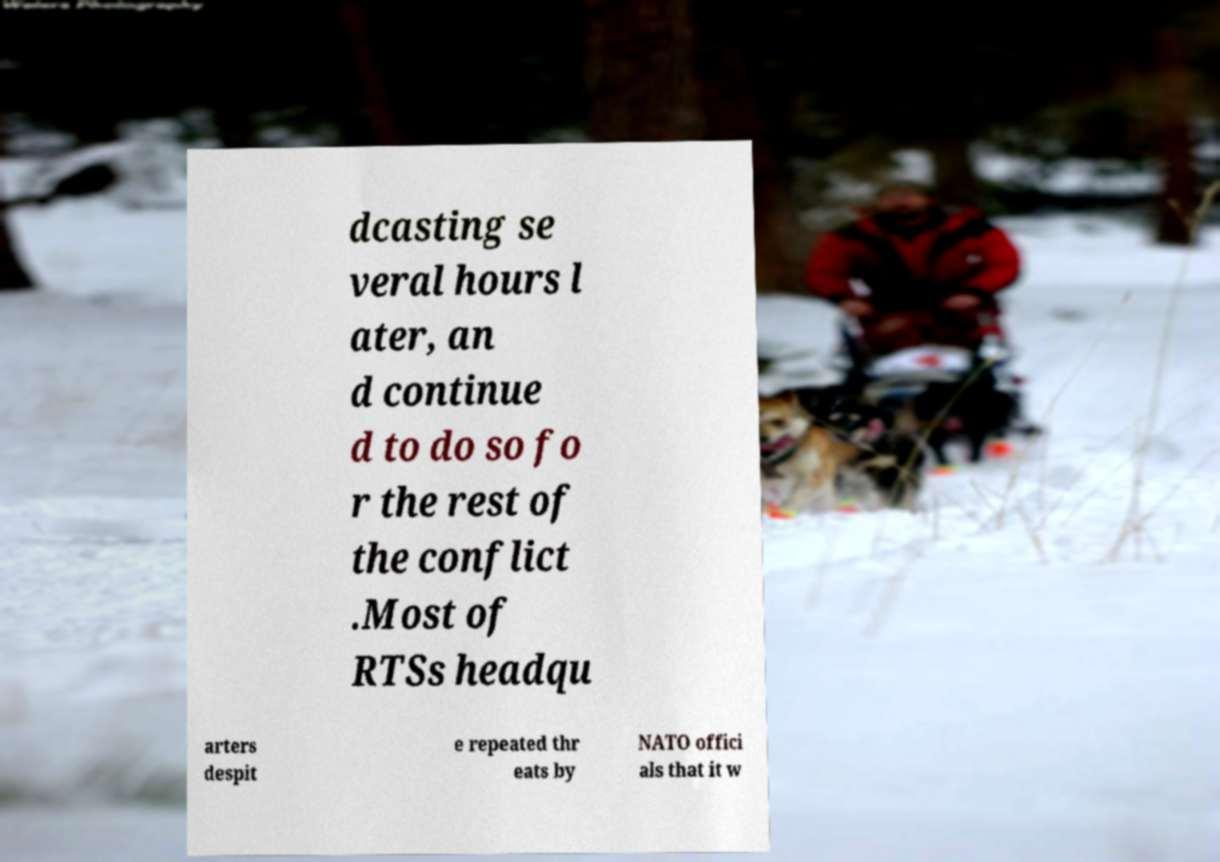Could you extract and type out the text from this image? dcasting se veral hours l ater, an d continue d to do so fo r the rest of the conflict .Most of RTSs headqu arters despit e repeated thr eats by NATO offici als that it w 